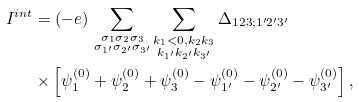<formula> <loc_0><loc_0><loc_500><loc_500>I ^ { i n t } & = ( - e ) \, \sum _ { \substack { \sigma _ { 1 } \sigma _ { 2 } \sigma _ { 3 } \\ \sigma _ { 1 ^ { \prime } } \sigma _ { 2 ^ { \prime } } \sigma _ { 3 ^ { \prime } } } } \sum _ { \substack { k _ { 1 } < 0 , k _ { 2 } k _ { 3 } \\ k _ { 1 ^ { \prime } } k _ { 2 ^ { \prime } } k _ { 3 ^ { \prime } } } } \Delta _ { 1 2 3 ; 1 ^ { \prime } 2 ^ { \prime } 3 ^ { \prime } } \\ & \times \left [ \psi _ { 1 } ^ { ( 0 ) } + \psi _ { 2 } ^ { ( 0 ) } + \psi _ { 3 } ^ { ( 0 ) } - \psi _ { 1 ^ { \prime } } ^ { ( 0 ) } - \psi _ { 2 ^ { \prime } } ^ { ( 0 ) } - \psi _ { 3 ^ { \prime } } ^ { ( 0 ) } \right ] ,</formula> 